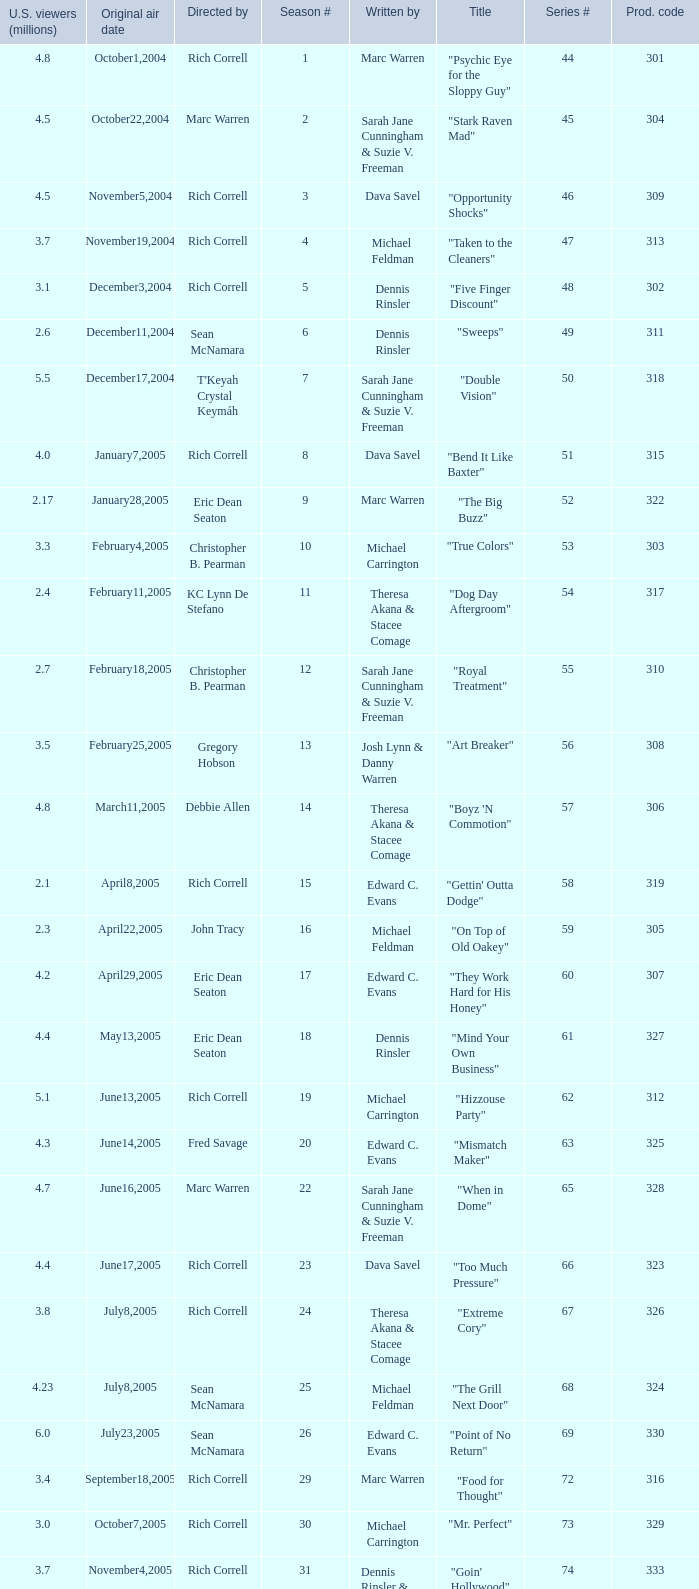What is the title of the episode directed by Rich Correll and written by Dennis Rinsler? "Five Finger Discount". 